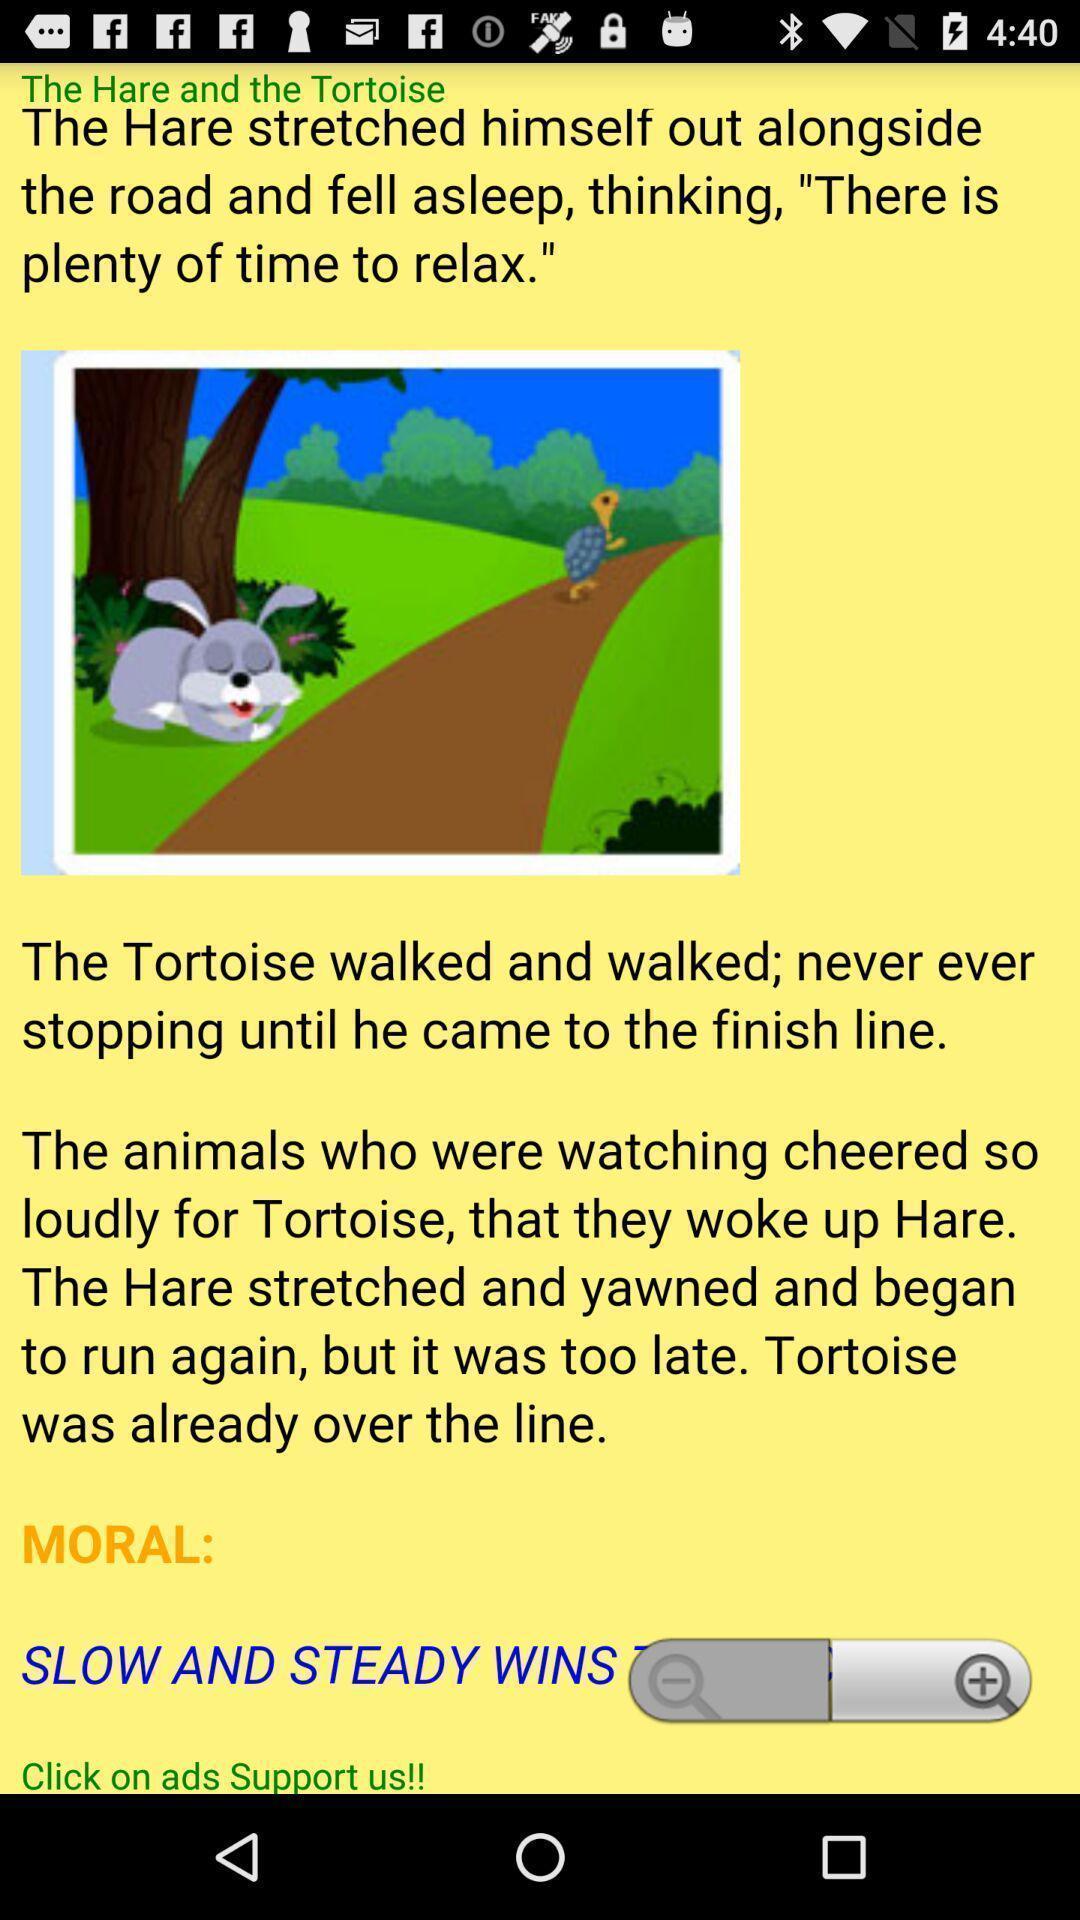What details can you identify in this image? Screen displaying story of a the hare and the tortoise. 